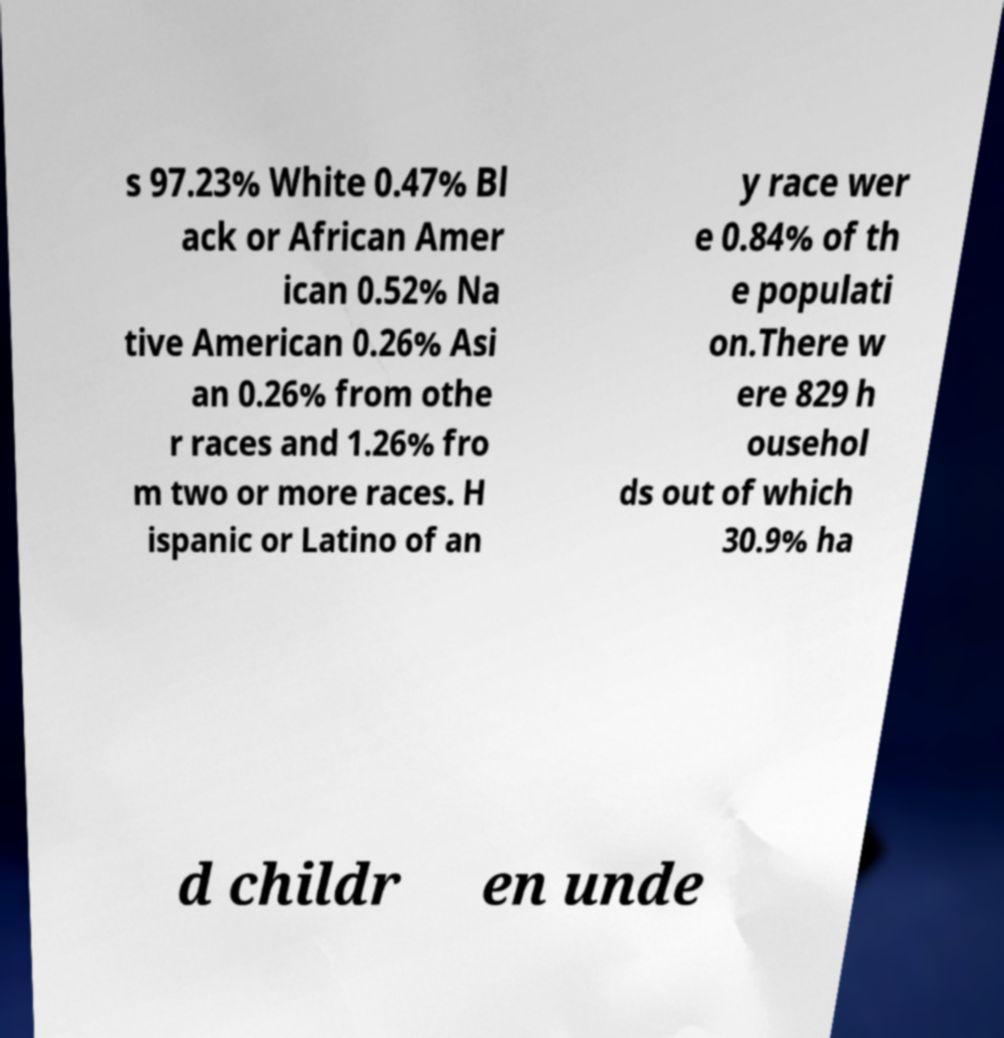What messages or text are displayed in this image? I need them in a readable, typed format. s 97.23% White 0.47% Bl ack or African Amer ican 0.52% Na tive American 0.26% Asi an 0.26% from othe r races and 1.26% fro m two or more races. H ispanic or Latino of an y race wer e 0.84% of th e populati on.There w ere 829 h ousehol ds out of which 30.9% ha d childr en unde 